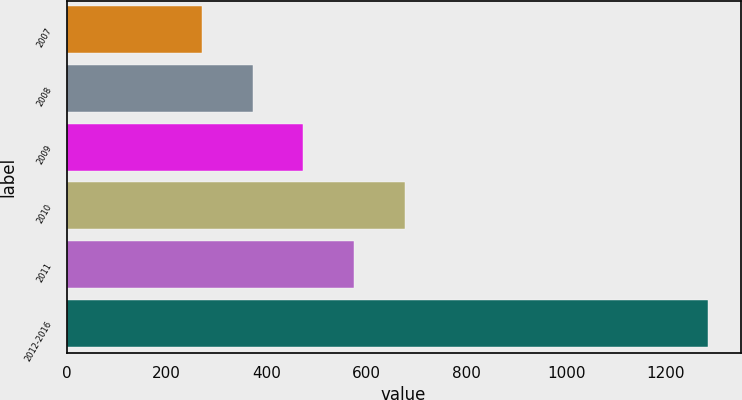Convert chart. <chart><loc_0><loc_0><loc_500><loc_500><bar_chart><fcel>2007<fcel>2008<fcel>2009<fcel>2010<fcel>2011<fcel>2012-2016<nl><fcel>271<fcel>372.4<fcel>473.8<fcel>676.6<fcel>575.2<fcel>1285<nl></chart> 